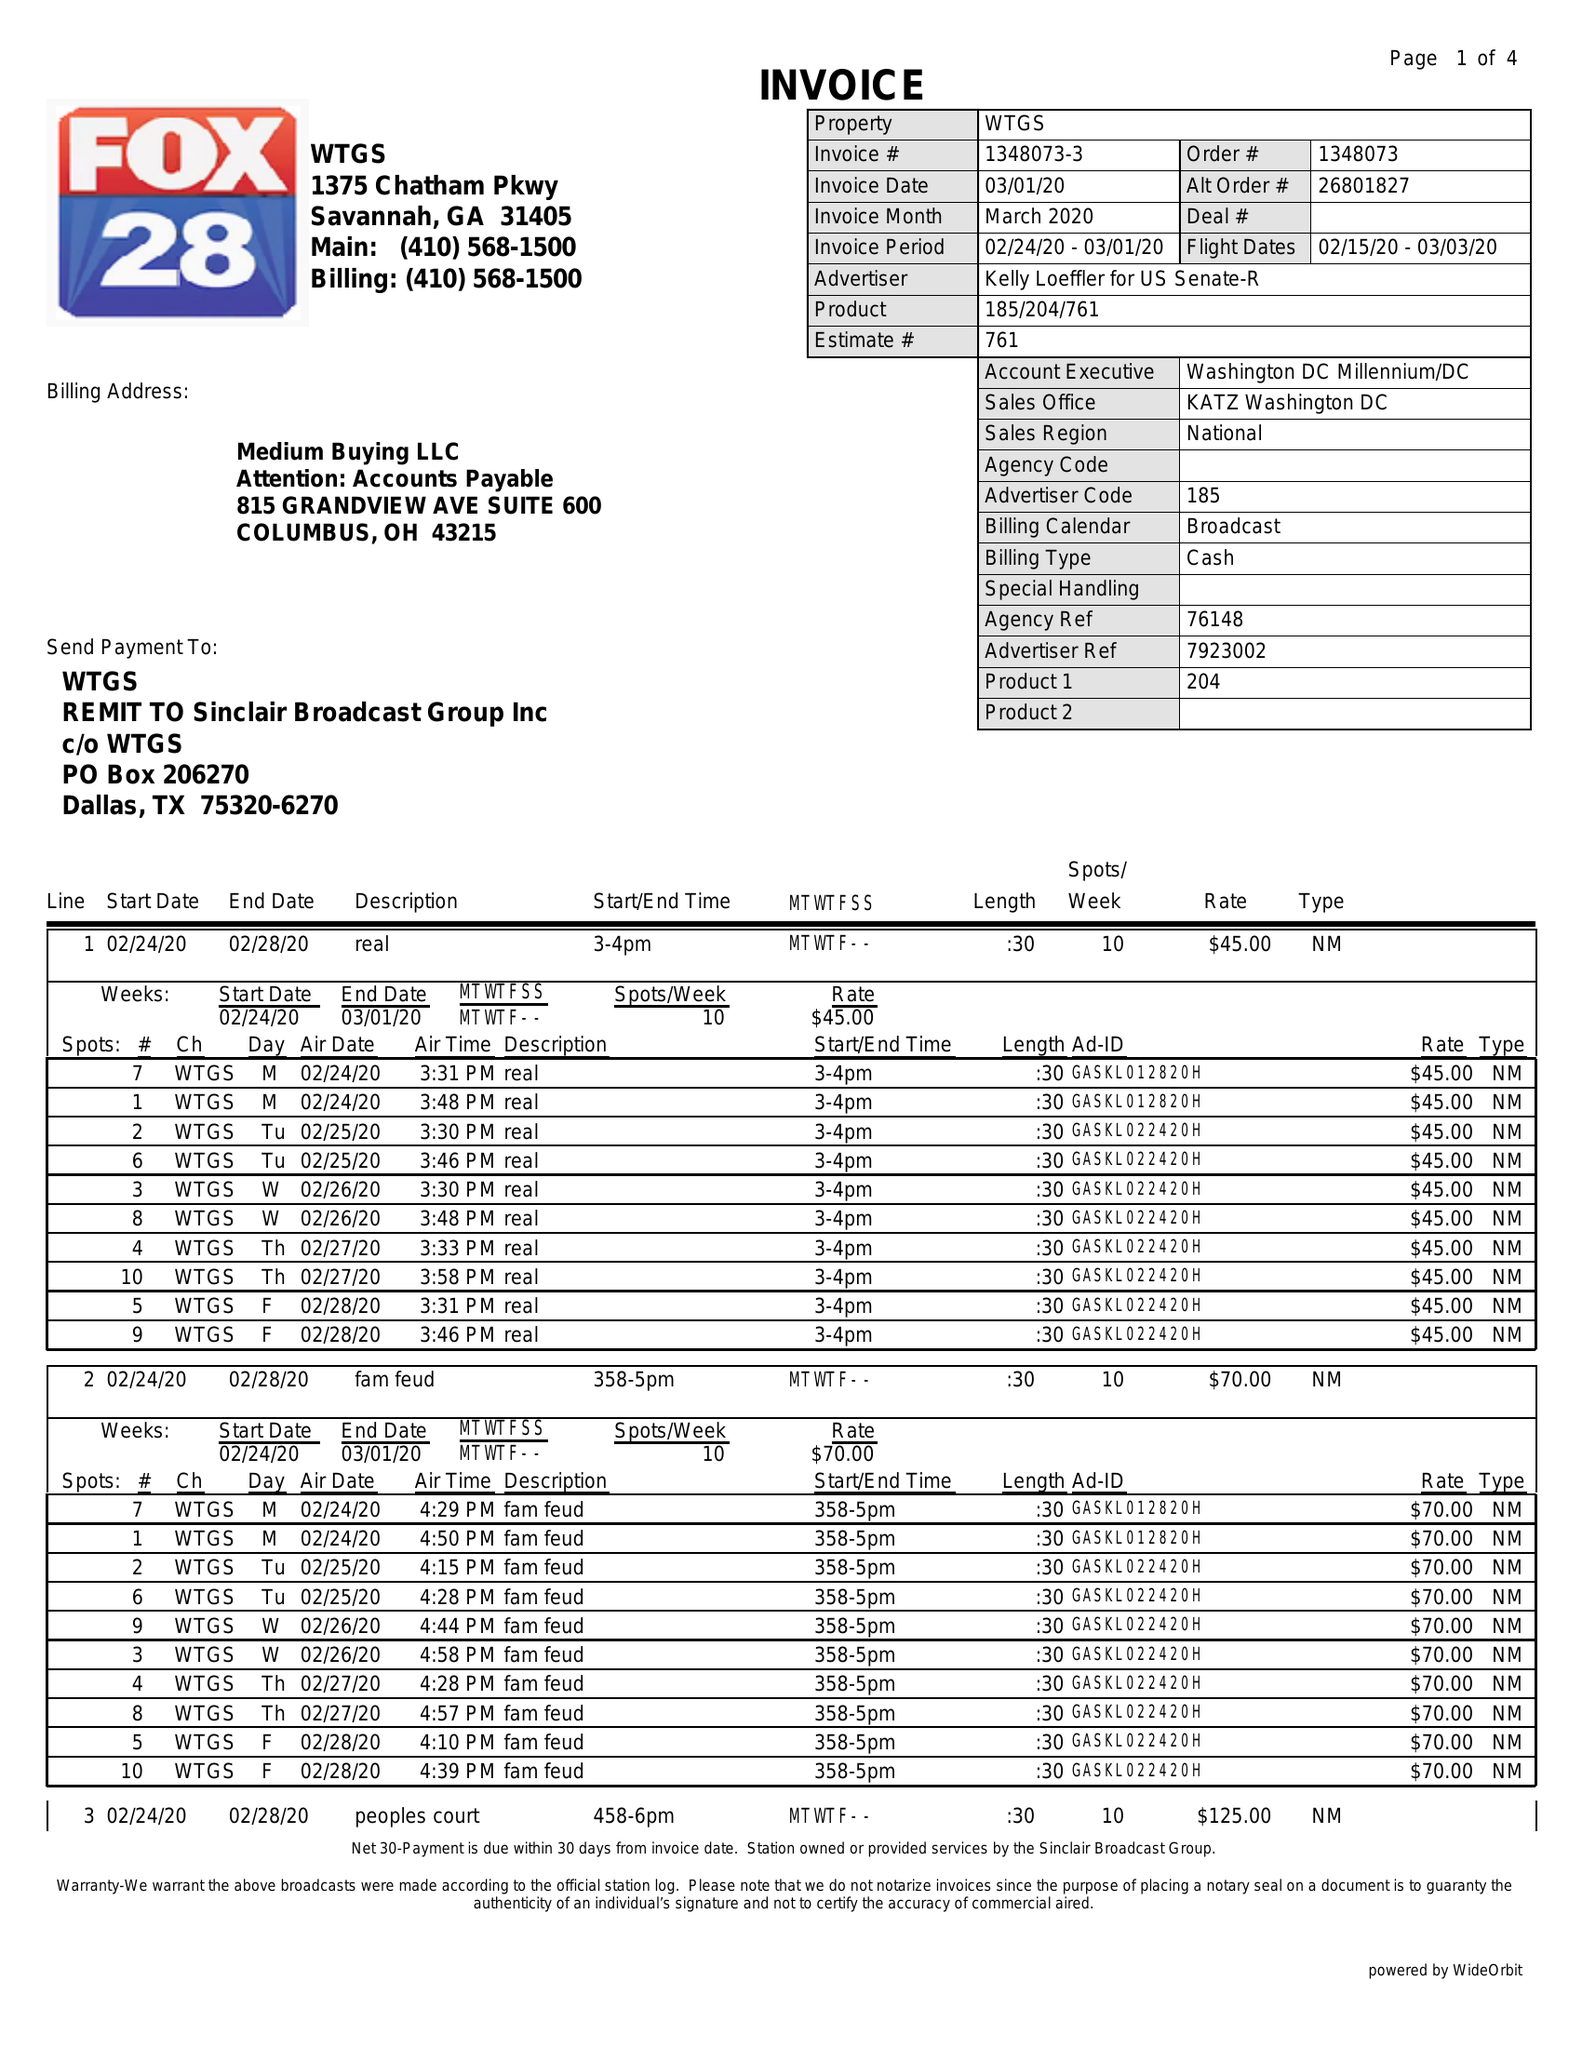What is the value for the advertiser?
Answer the question using a single word or phrase. KELLY LOEFFLER FOR US SENATE 